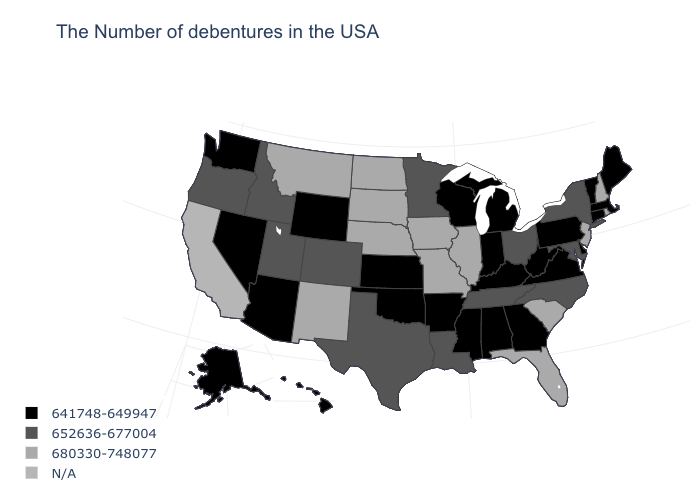Which states hav the highest value in the MidWest?
Concise answer only. Illinois, Missouri, Iowa, Nebraska, South Dakota, North Dakota. What is the value of Maine?
Short answer required. 641748-649947. What is the lowest value in the Northeast?
Concise answer only. 641748-649947. Which states have the lowest value in the West?
Concise answer only. Wyoming, Arizona, Nevada, Washington, Alaska, Hawaii. Among the states that border Idaho , does Montana have the highest value?
Answer briefly. Yes. What is the value of Oregon?
Write a very short answer. 652636-677004. Which states hav the highest value in the Northeast?
Quick response, please. Rhode Island, New Hampshire, New Jersey. What is the value of Michigan?
Keep it brief. 641748-649947. What is the value of Louisiana?
Quick response, please. 652636-677004. Does the first symbol in the legend represent the smallest category?
Keep it brief. Yes. Name the states that have a value in the range 641748-649947?
Answer briefly. Maine, Massachusetts, Vermont, Connecticut, Delaware, Pennsylvania, Virginia, West Virginia, Georgia, Michigan, Kentucky, Indiana, Alabama, Wisconsin, Mississippi, Arkansas, Kansas, Oklahoma, Wyoming, Arizona, Nevada, Washington, Alaska, Hawaii. Does Mississippi have the lowest value in the USA?
Answer briefly. Yes. What is the value of Virginia?
Be succinct. 641748-649947. Among the states that border Nebraska , does Wyoming have the lowest value?
Quick response, please. Yes. 